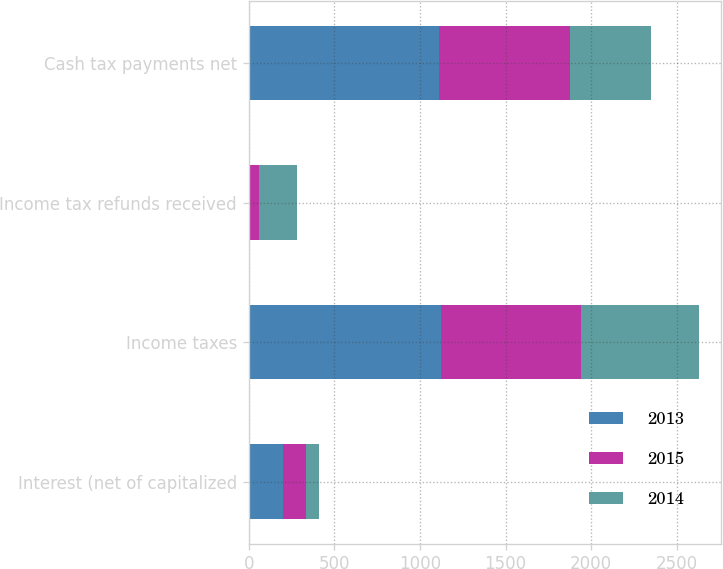<chart> <loc_0><loc_0><loc_500><loc_500><stacked_bar_chart><ecel><fcel>Interest (net of capitalized<fcel>Income taxes<fcel>Income tax refunds received<fcel>Cash tax payments net<nl><fcel>2013<fcel>201<fcel>1122<fcel>9<fcel>1113<nl><fcel>2015<fcel>131<fcel>820<fcel>54<fcel>766<nl><fcel>2014<fcel>80<fcel>687<fcel>219<fcel>468<nl></chart> 